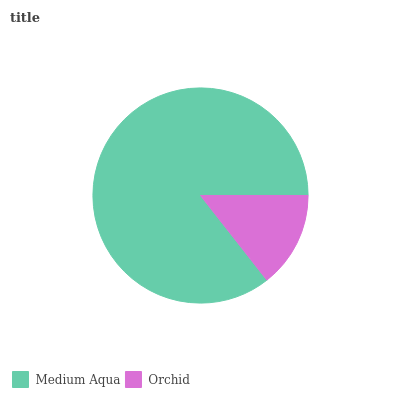Is Orchid the minimum?
Answer yes or no. Yes. Is Medium Aqua the maximum?
Answer yes or no. Yes. Is Orchid the maximum?
Answer yes or no. No. Is Medium Aqua greater than Orchid?
Answer yes or no. Yes. Is Orchid less than Medium Aqua?
Answer yes or no. Yes. Is Orchid greater than Medium Aqua?
Answer yes or no. No. Is Medium Aqua less than Orchid?
Answer yes or no. No. Is Medium Aqua the high median?
Answer yes or no. Yes. Is Orchid the low median?
Answer yes or no. Yes. Is Orchid the high median?
Answer yes or no. No. Is Medium Aqua the low median?
Answer yes or no. No. 